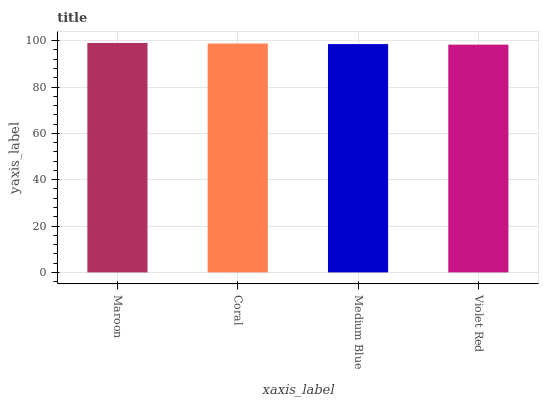Is Violet Red the minimum?
Answer yes or no. Yes. Is Maroon the maximum?
Answer yes or no. Yes. Is Coral the minimum?
Answer yes or no. No. Is Coral the maximum?
Answer yes or no. No. Is Maroon greater than Coral?
Answer yes or no. Yes. Is Coral less than Maroon?
Answer yes or no. Yes. Is Coral greater than Maroon?
Answer yes or no. No. Is Maroon less than Coral?
Answer yes or no. No. Is Coral the high median?
Answer yes or no. Yes. Is Medium Blue the low median?
Answer yes or no. Yes. Is Maroon the high median?
Answer yes or no. No. Is Violet Red the low median?
Answer yes or no. No. 